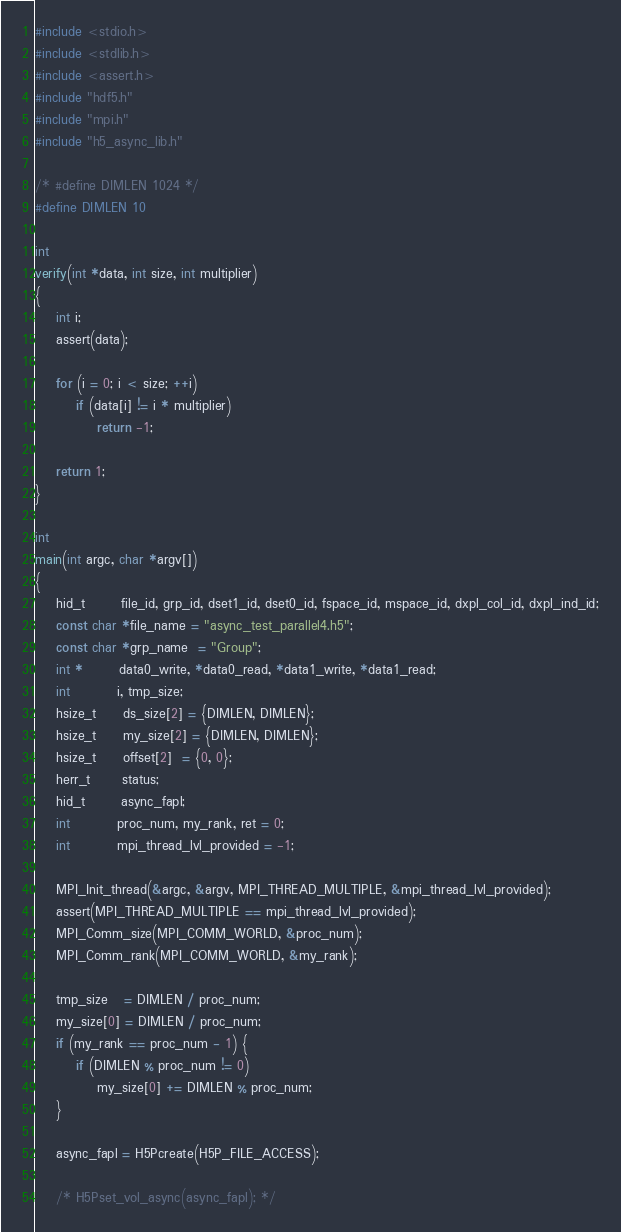<code> <loc_0><loc_0><loc_500><loc_500><_C_>#include <stdio.h>
#include <stdlib.h>
#include <assert.h>
#include "hdf5.h"
#include "mpi.h"
#include "h5_async_lib.h"

/* #define DIMLEN 1024 */
#define DIMLEN 10

int
verify(int *data, int size, int multiplier)
{
    int i;
    assert(data);

    for (i = 0; i < size; ++i)
        if (data[i] != i * multiplier)
            return -1;

    return 1;
}

int
main(int argc, char *argv[])
{
    hid_t       file_id, grp_id, dset1_id, dset0_id, fspace_id, mspace_id, dxpl_col_id, dxpl_ind_id;
    const char *file_name = "async_test_parallel4.h5";
    const char *grp_name  = "Group";
    int *       data0_write, *data0_read, *data1_write, *data1_read;
    int         i, tmp_size;
    hsize_t     ds_size[2] = {DIMLEN, DIMLEN};
    hsize_t     my_size[2] = {DIMLEN, DIMLEN};
    hsize_t     offset[2]  = {0, 0};
    herr_t      status;
    hid_t       async_fapl;
    int         proc_num, my_rank, ret = 0;
    int         mpi_thread_lvl_provided = -1;

    MPI_Init_thread(&argc, &argv, MPI_THREAD_MULTIPLE, &mpi_thread_lvl_provided);
    assert(MPI_THREAD_MULTIPLE == mpi_thread_lvl_provided);
    MPI_Comm_size(MPI_COMM_WORLD, &proc_num);
    MPI_Comm_rank(MPI_COMM_WORLD, &my_rank);

    tmp_size   = DIMLEN / proc_num;
    my_size[0] = DIMLEN / proc_num;
    if (my_rank == proc_num - 1) {
        if (DIMLEN % proc_num != 0)
            my_size[0] += DIMLEN % proc_num;
    }

    async_fapl = H5Pcreate(H5P_FILE_ACCESS);

    /* H5Pset_vol_async(async_fapl); */</code> 